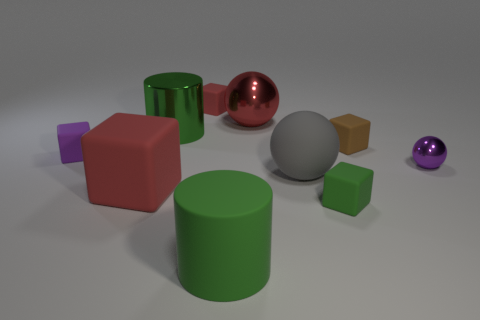There is a tiny red thing; what number of red rubber cubes are in front of it?
Offer a terse response. 1. Is there a gray sphere of the same size as the gray object?
Your response must be concise. No. Do the large red thing that is on the right side of the green shiny thing and the tiny shiny object have the same shape?
Your answer should be compact. Yes. What color is the big rubber block?
Ensure brevity in your answer.  Red. What shape is the tiny thing that is the same color as the large metallic cylinder?
Offer a very short reply. Cube. Are there any tiny red blocks?
Make the answer very short. Yes. The red sphere that is made of the same material as the purple sphere is what size?
Keep it short and to the point. Large. There is a shiny thing on the left side of the large red thing right of the large thing in front of the tiny green rubber cube; what is its shape?
Keep it short and to the point. Cylinder. Is the number of cylinders that are behind the big red sphere the same as the number of blue rubber balls?
Ensure brevity in your answer.  Yes. What size is the matte cylinder that is the same color as the shiny cylinder?
Offer a terse response. Large. 